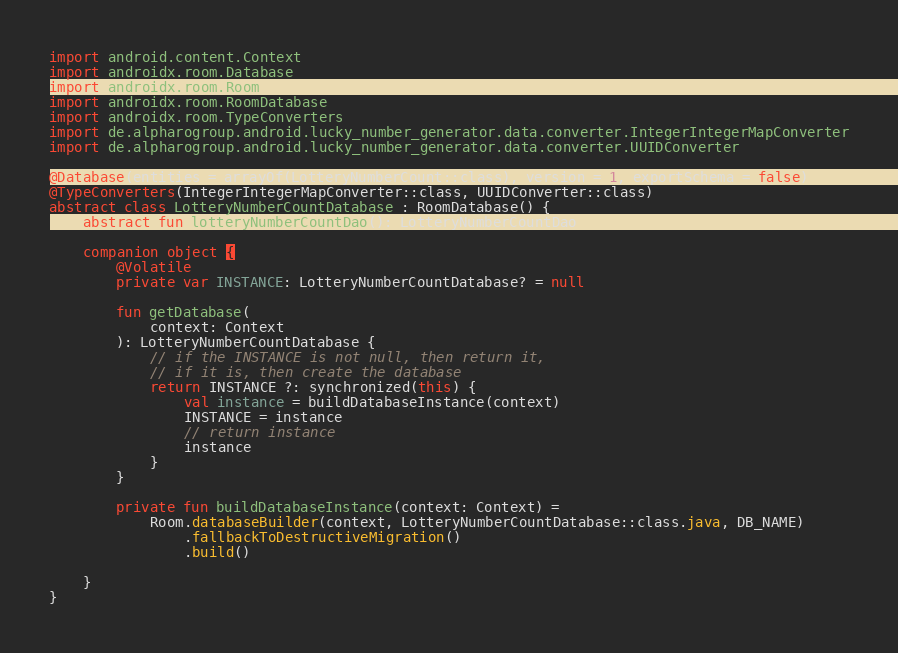<code> <loc_0><loc_0><loc_500><loc_500><_Kotlin_>
import android.content.Context
import androidx.room.Database
import androidx.room.Room
import androidx.room.RoomDatabase
import androidx.room.TypeConverters
import de.alpharogroup.android.lucky_number_generator.data.converter.IntegerIntegerMapConverter
import de.alpharogroup.android.lucky_number_generator.data.converter.UUIDConverter

@Database(entities = arrayOf(LotteryNumberCount::class), version = 1, exportSchema = false)
@TypeConverters(IntegerIntegerMapConverter::class, UUIDConverter::class)
abstract class LotteryNumberCountDatabase : RoomDatabase() {
    abstract fun lotteryNumberCountDao(): LotteryNumberCountDao

    companion object {
        @Volatile
        private var INSTANCE: LotteryNumberCountDatabase? = null

        fun getDatabase(
            context: Context
        ): LotteryNumberCountDatabase {
            // if the INSTANCE is not null, then return it,
            // if it is, then create the database
            return INSTANCE ?: synchronized(this) {
                val instance = buildDatabaseInstance(context)
                INSTANCE = instance
                // return instance
                instance
            }
        }

        private fun buildDatabaseInstance(context: Context) =
            Room.databaseBuilder(context, LotteryNumberCountDatabase::class.java, DB_NAME)
                .fallbackToDestructiveMigration()
                .build()

    }
}</code> 